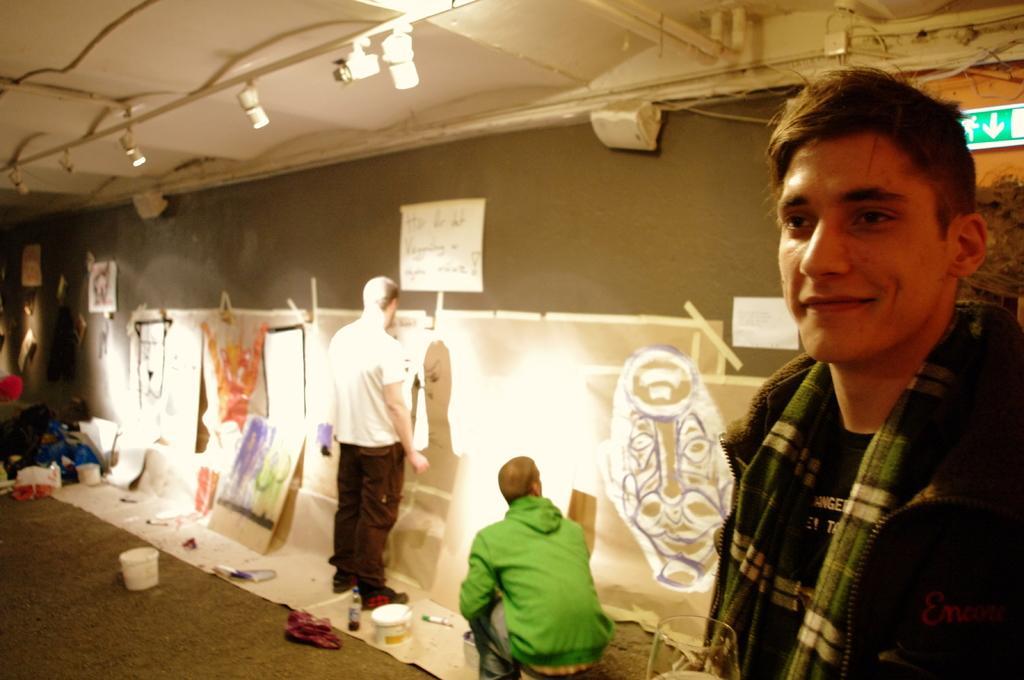Can you describe this image briefly? There is a man standing and smiling,behind this man we can see sign board. Here we can see board,buckets and objects on the surface. There are two people. Top we can see lights. 